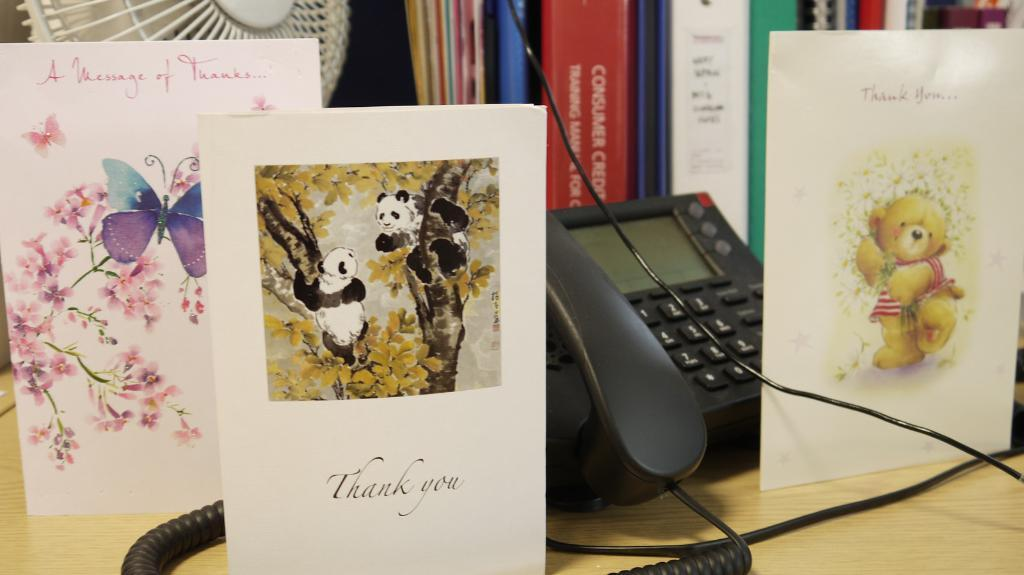What type of items can be seen on the table in the image? There are greeting cards, a telephone, books, and a table fan on the table in the image. Can you describe the purpose of each item on the table? The greeting cards are likely for sending messages or expressing sentiments, the telephone is for communication, the books are for reading or reference, and the table fan is for cooling the air. What is the common feature of all these items? They are all objects that can be found in an office or study setting. What type of suit is the person wearing in the image? There is no person present in the image, so it is not possible to determine what type of suit they might be wearing. 